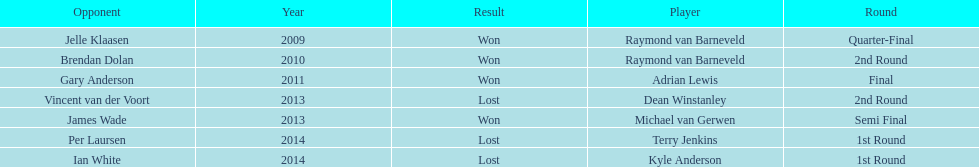Parse the full table. {'header': ['Opponent', 'Year', 'Result', 'Player', 'Round'], 'rows': [['Jelle Klaasen', '2009', 'Won', 'Raymond van Barneveld', 'Quarter-Final'], ['Brendan Dolan', '2010', 'Won', 'Raymond van Barneveld', '2nd Round'], ['Gary Anderson', '2011', 'Won', 'Adrian Lewis', 'Final'], ['Vincent van der Voort', '2013', 'Lost', 'Dean Winstanley', '2nd Round'], ['James Wade', '2013', 'Won', 'Michael van Gerwen', 'Semi Final'], ['Per Laursen', '2014', 'Lost', 'Terry Jenkins', '1st Round'], ['Ian White', '2014', 'Lost', 'Kyle Anderson', '1st Round']]} Who won the first world darts championship? Raymond van Barneveld. 